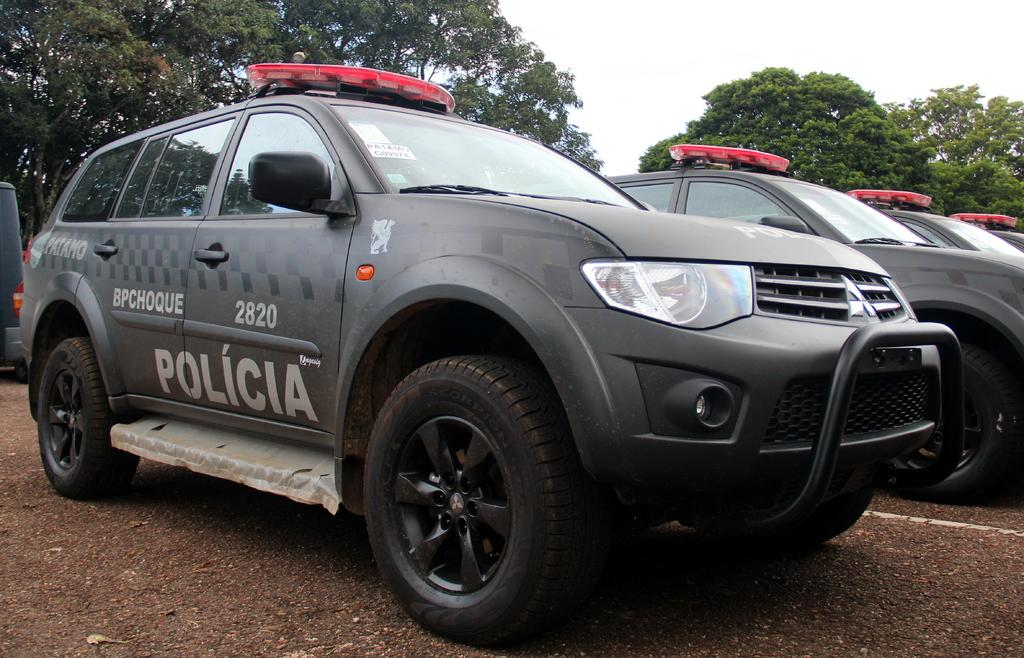What is the main subject in the center of the image? There are cars in the center of the image. What can be seen in the background of the image? There are trees in the background of the image. What is at the bottom of the image? There is a road at the bottom of the image. What type of plate is being smashed by the father in the image? There is no plate or father present in the image; it only features cars, trees, and a road. 